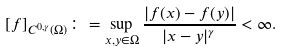Convert formula to latex. <formula><loc_0><loc_0><loc_500><loc_500>[ f ] _ { C ^ { 0 , \gamma } ( \Omega ) } \colon = \sup _ { x , y \in \Omega } \frac { | f ( x ) - f ( y ) | } { | x - y | ^ { \gamma } } < \infty .</formula> 